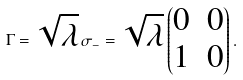<formula> <loc_0><loc_0><loc_500><loc_500>\Gamma = \sqrt { \lambda } \, \sigma _ { - } = \sqrt { \lambda } \begin{pmatrix} 0 & 0 \\ 1 & 0 \end{pmatrix} .</formula> 